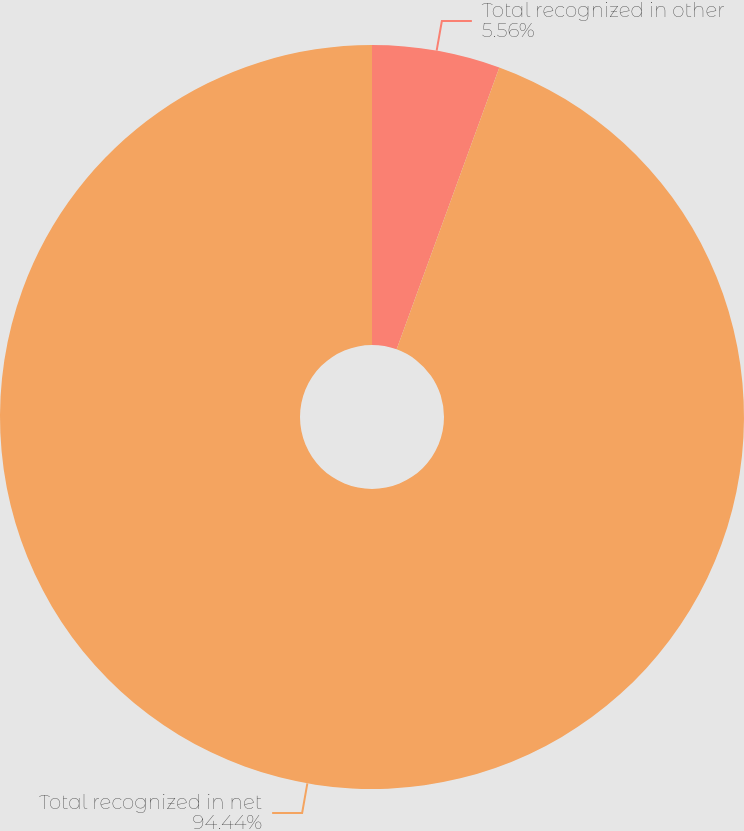Convert chart. <chart><loc_0><loc_0><loc_500><loc_500><pie_chart><fcel>Total recognized in other<fcel>Total recognized in net<nl><fcel>5.56%<fcel>94.44%<nl></chart> 